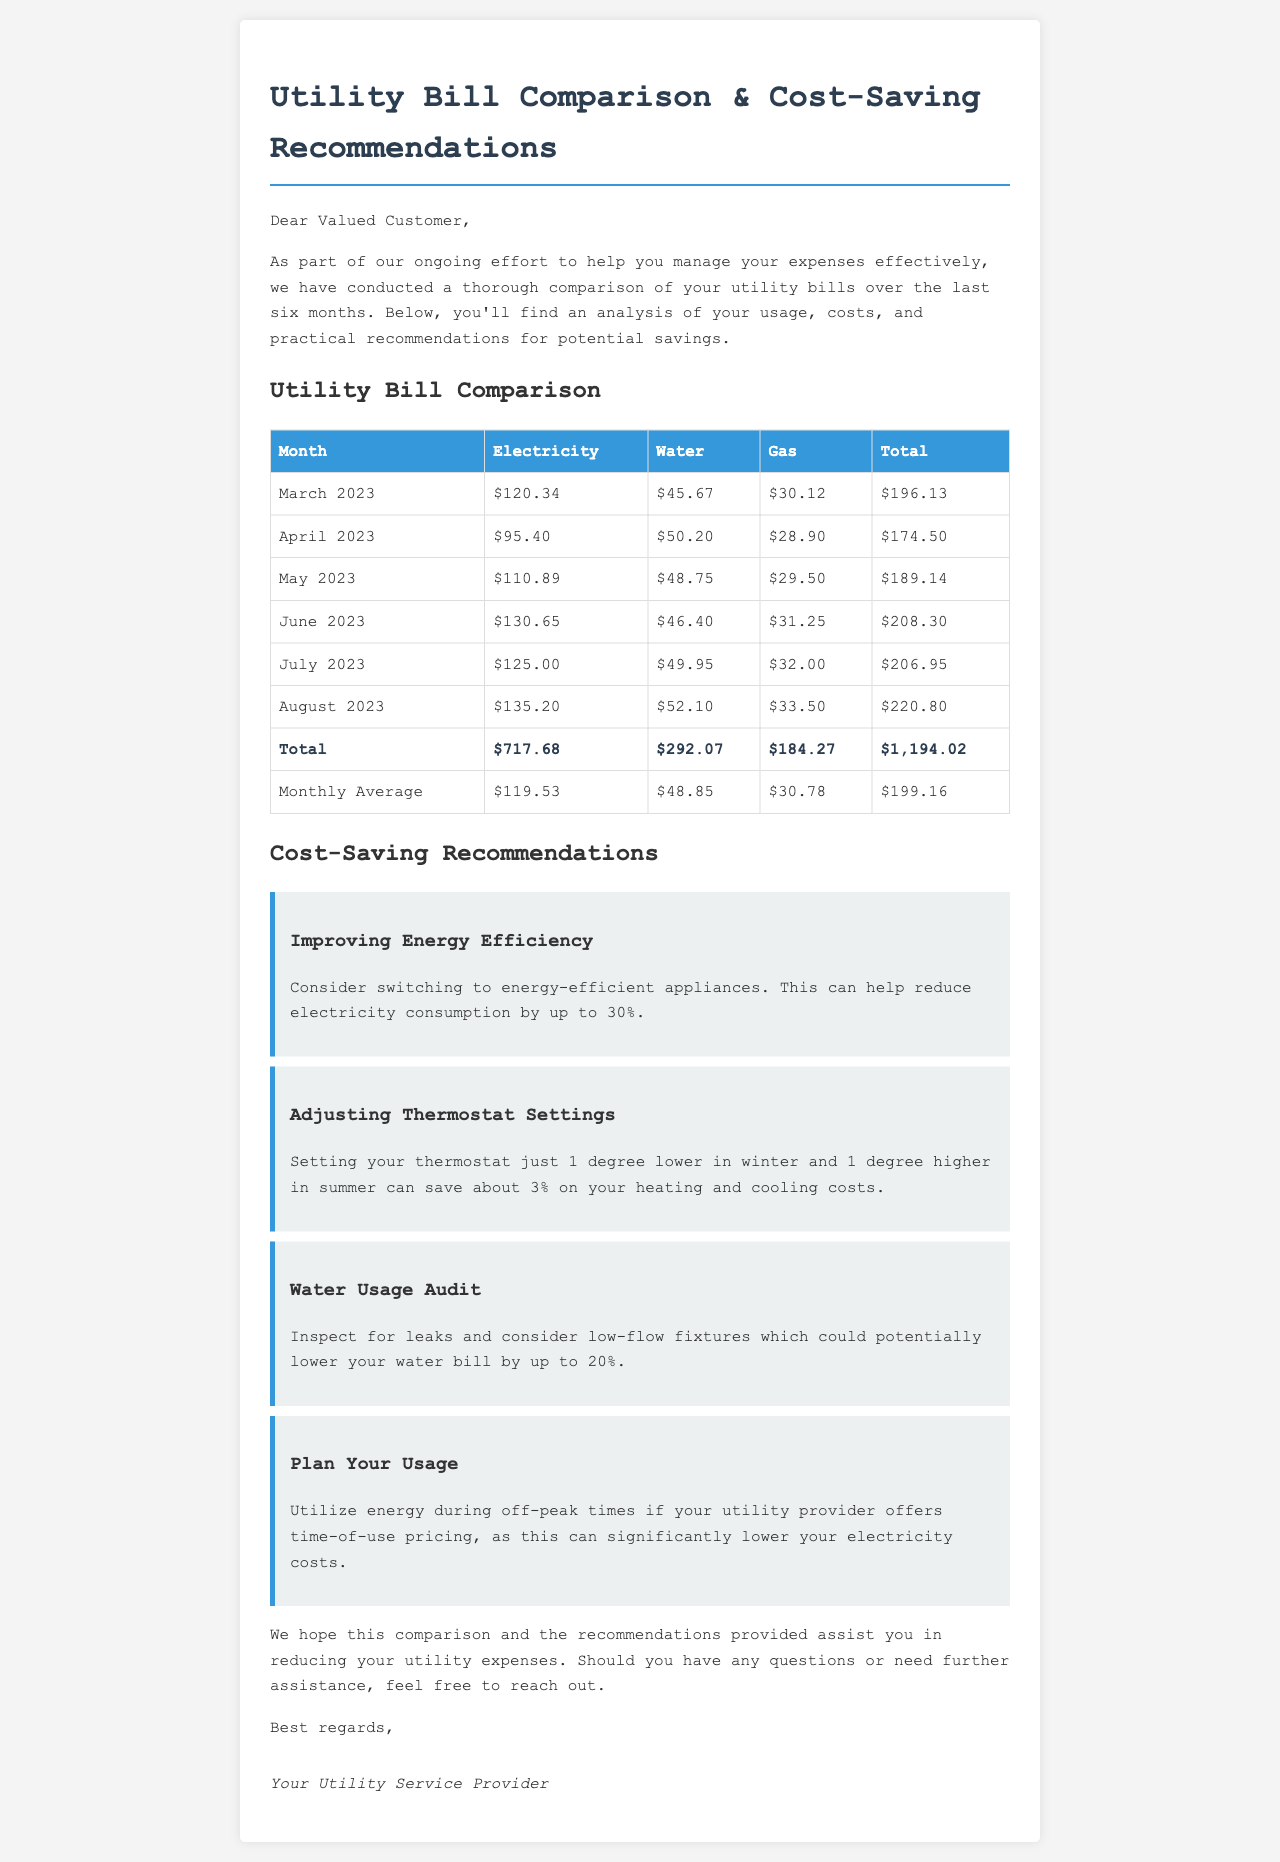What was the total amount spent on water over six months? The total amount spent on water is found by adding the individual monthly water costs together, which is $292.07.
Answer: $292.07 What is the highest electricity bill recorded? The highest electricity bill can be identified in the table as $135.20 for August 2023.
Answer: $135.20 What month had the lowest total utility bill? The month with the lowest total utility bill is April 2023, which is $174.50.
Answer: April 2023 How much could electricity consumption potentially be reduced by switching to energy-efficient appliances? The document mentions that this can help reduce electricity consumption by up to 30%.
Answer: 30% What are the recommendations for saving on water bills? The recommendation provided is to inspect for leaks and consider low-flow fixtures, potentially lowering the bill by up to 20%.
Answer: 20% What is the average total utility bill per month? The average total utility bill is calculated and shown in the document as $199.16.
Answer: $199.16 What action is suggested for thermostat settings to save costs? The document suggests setting the thermostat just 1 degree lower in winter and 1 degree higher in summer.
Answer: 1 degree How many months of data are provided in this comparison? There are six months of data provided in the comparison.
Answer: Six months Which company provided this utility bill comparison? The document is signed off by "Your Utility Service Provider," indicating they provided the comparison.
Answer: Your Utility Service Provider 